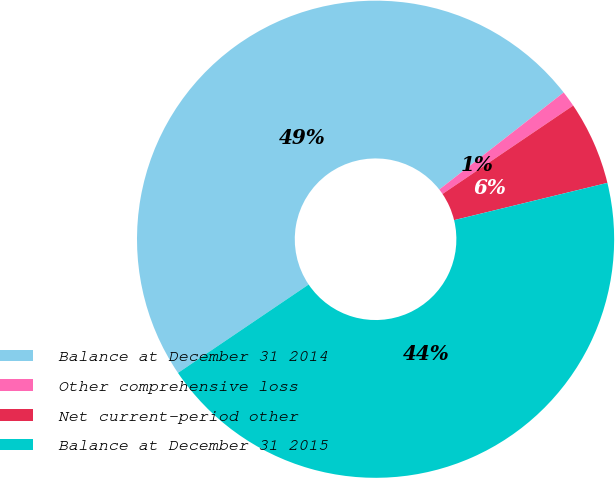Convert chart. <chart><loc_0><loc_0><loc_500><loc_500><pie_chart><fcel>Balance at December 31 2014<fcel>Other comprehensive loss<fcel>Net current-period other<fcel>Balance at December 31 2015<nl><fcel>48.92%<fcel>1.08%<fcel>5.67%<fcel>44.33%<nl></chart> 